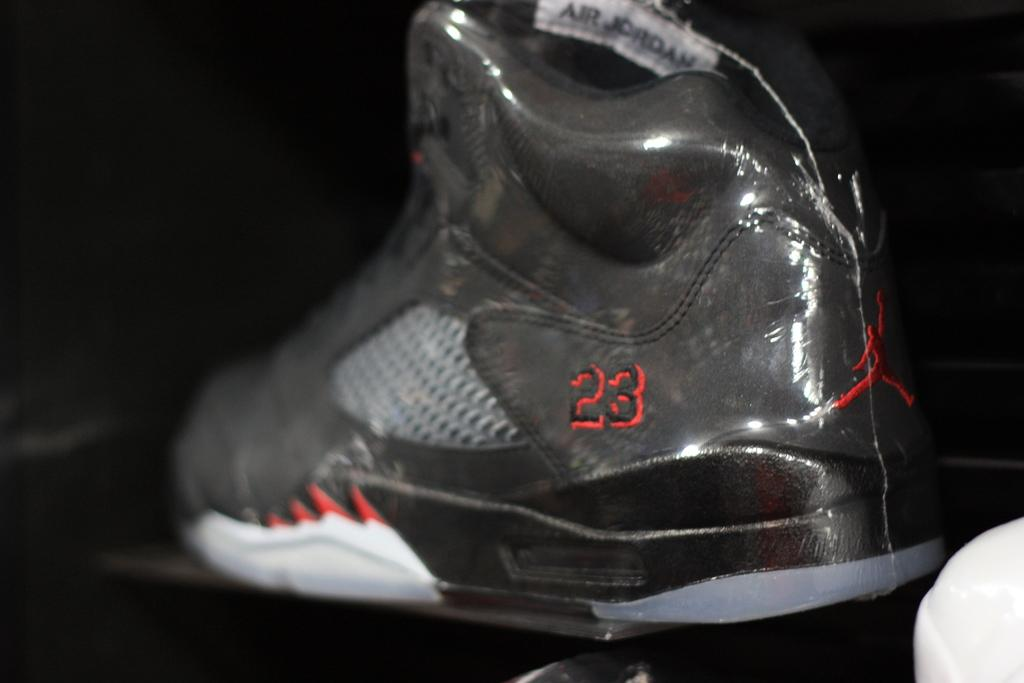What is placed on the table in the image? There is a shoe on the table in the image. What can be seen on the floor in the image? There are objects on the floor in the image. What color is the background of the image? The background of the image is black. What type of quill is being used to balance the shoe on the table in the image? There is no quill present in the image, and the shoe is not being balanced on the table. 